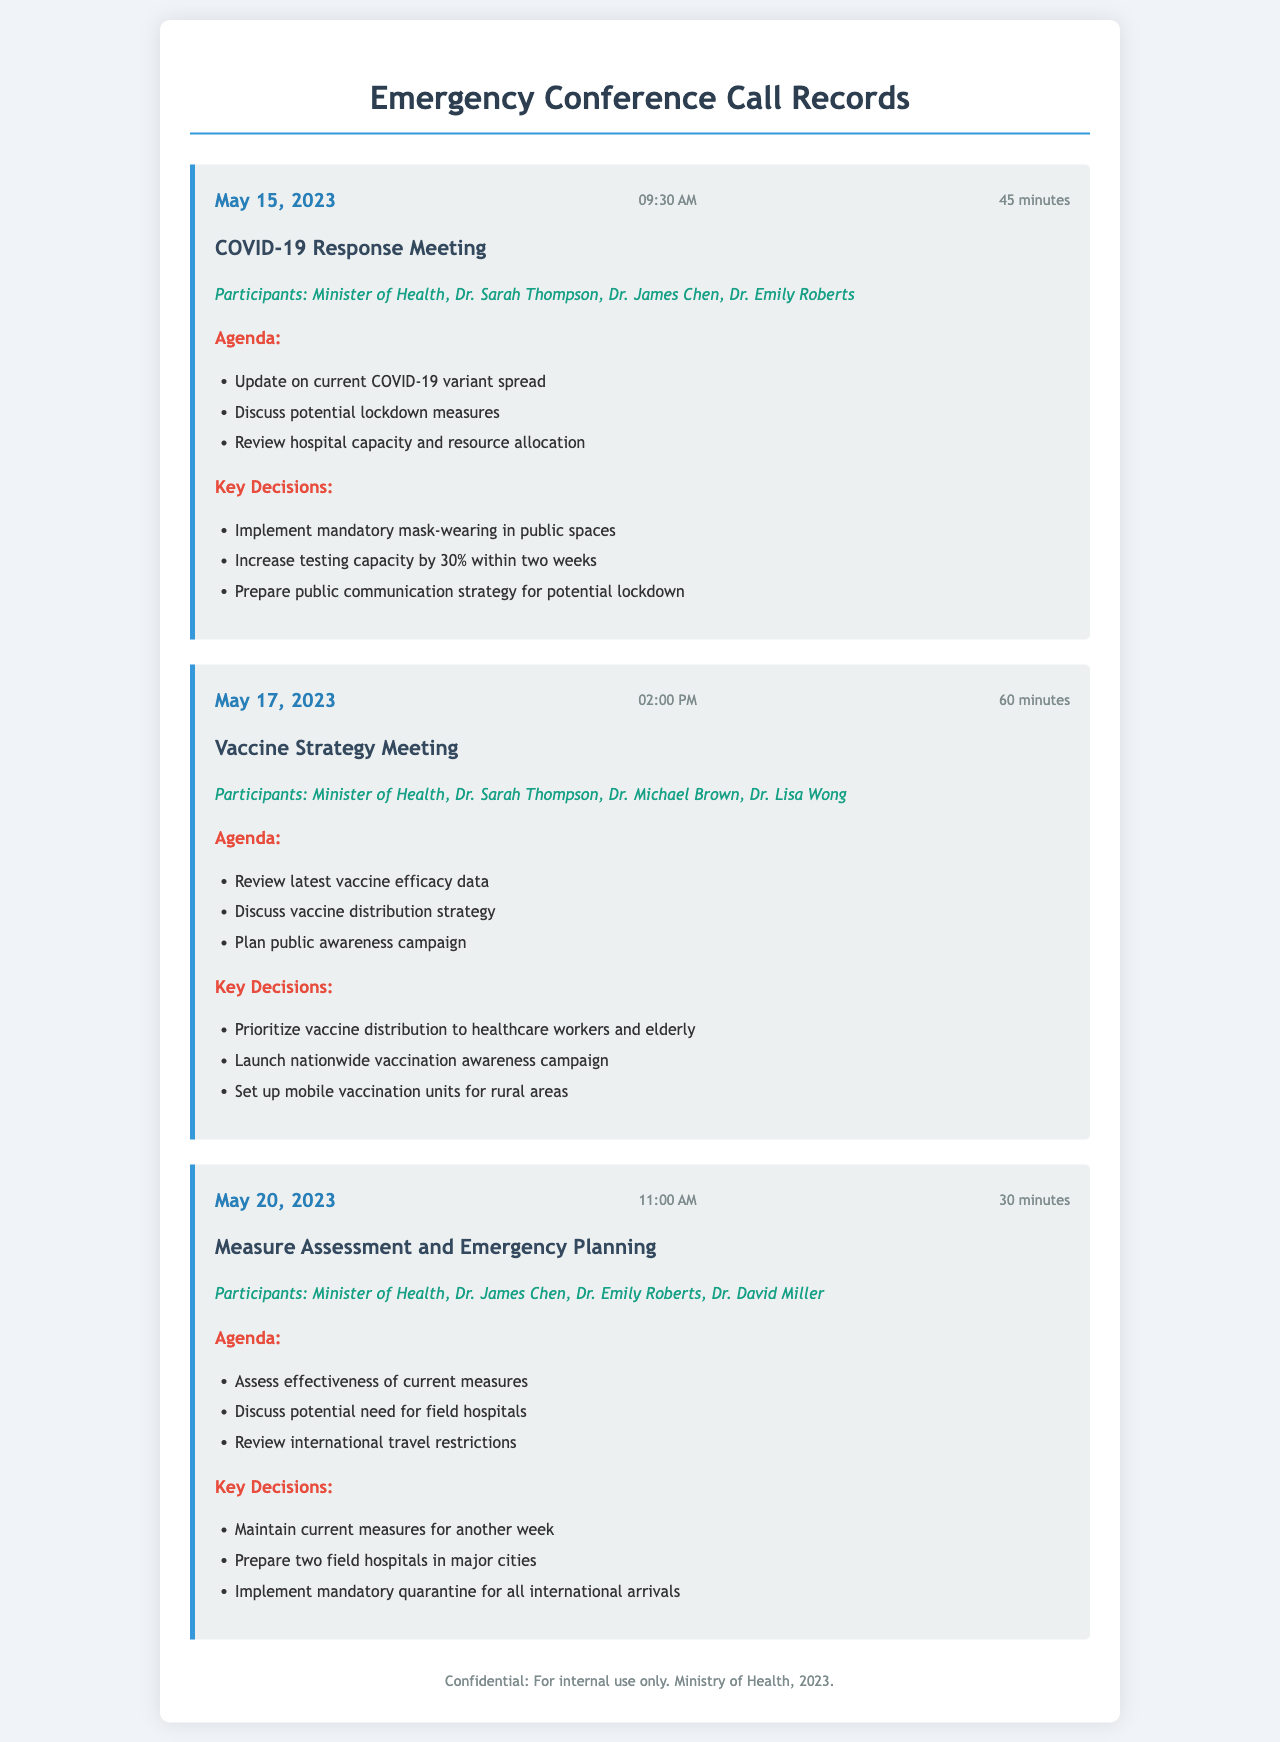What was the date of the COVID-19 response meeting? The date is explicitly stated in the document under the call record for the COVID-19 Response Meeting.
Answer: May 15, 2023 Who participated in the Vaccine Strategy Meeting? The participants are listed under the respective call record for the Vaccine Strategy Meeting.
Answer: Minister of Health, Dr. Sarah Thompson, Dr. Michael Brown, Dr. Lisa Wong How long was the Measure Assessment and Emergency Planning call? The duration is indicated in the call header of the Measure Assessment and Emergency Planning call record.
Answer: 30 minutes What key decision was made regarding vaccine distribution? The key decisions are outlined under the Vaccine Strategy Meeting section.
Answer: Prioritize vaccine distribution to healthcare workers and elderly On what date was the call regarding the potential need for field hospitals held? The date is mentioned in the call record for Measure Assessment and Emergency Planning.
Answer: May 20, 2023 What was one agenda item discussed in the COVID-19 response meeting? The agenda items are listed under the COVID-19 Response Meeting section.
Answer: Update on current COVID-19 variant spread What is the time of the call held on May 17, 2023? The time is provided in the call header of the Vaccine Strategy Meeting call record.
Answer: 02:00 PM What decision was made regarding international arrivals? The decisions are listed in the Measure Assessment and Emergency Planning record.
Answer: Implement mandatory quarantine for all international arrivals 